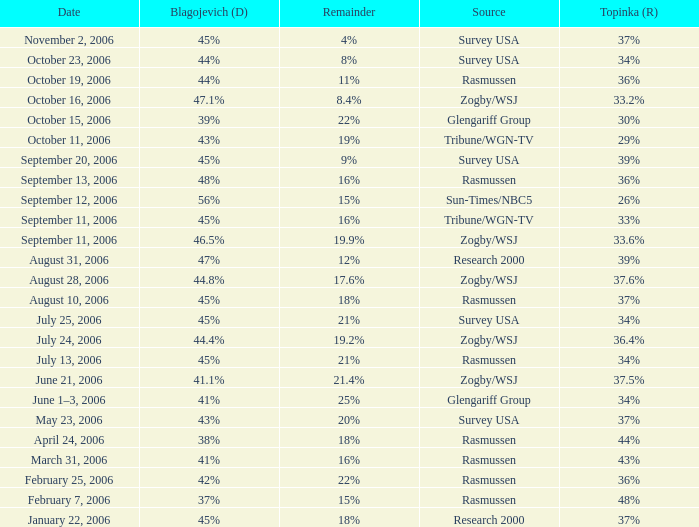Which Date has a Remainder of 20%? May 23, 2006. 